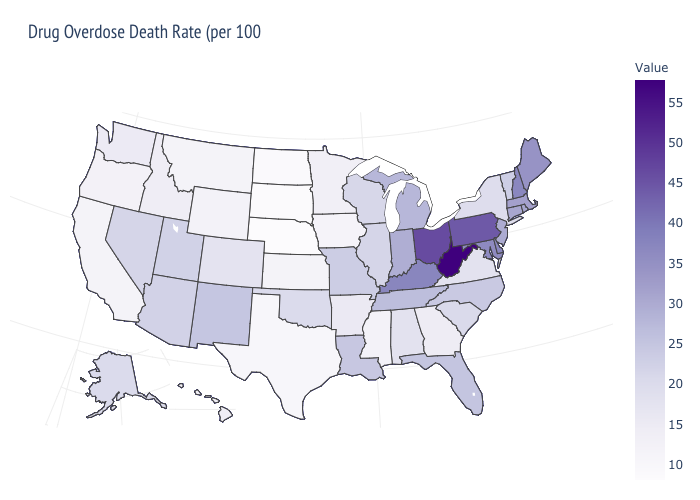Is the legend a continuous bar?
Short answer required. Yes. Does Oregon have the highest value in the West?
Answer briefly. No. Which states hav the highest value in the MidWest?
Concise answer only. Ohio. Does New York have a higher value than California?
Quick response, please. Yes. Does Ohio have the lowest value in the MidWest?
Be succinct. No. Among the states that border Michigan , which have the lowest value?
Concise answer only. Wisconsin. 